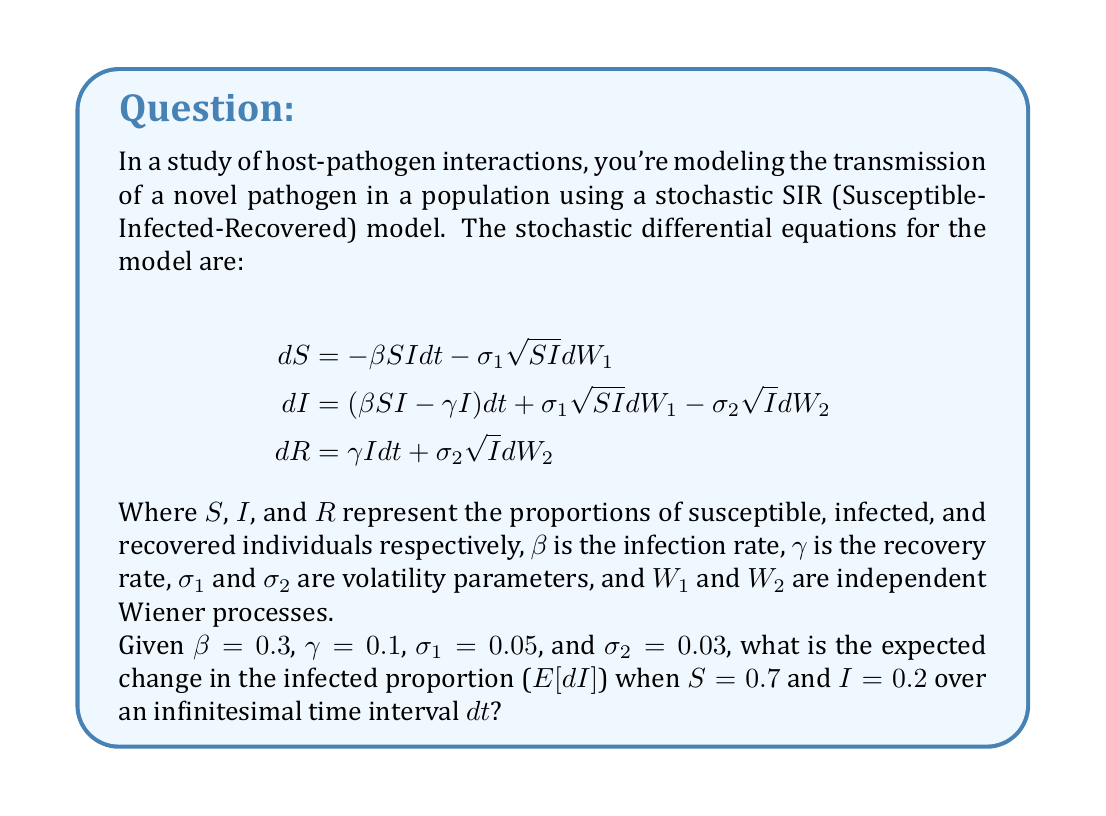Help me with this question. To solve this problem, we need to focus on the equation for $dI$ and calculate its expectation. Let's break it down step-by-step:

1) The stochastic differential equation for $dI$ is:

   $$dI = (\beta SI - \gamma I) dt + \sigma_1 \sqrt{SI} dW_1 - \sigma_2 \sqrt{I} dW_2$$

2) To find $E[dI]$, we need to take the expectation of both sides. The expectation of the Wiener process increments ($dW_1$ and $dW_2$) is zero, so these terms will disappear:

   $$E[dI] = E[(\beta SI - \gamma I) dt + \sigma_1 \sqrt{SI} dW_1 - \sigma_2 \sqrt{I} dW_2]$$
   $$E[dI] = (\beta SI - \gamma I) dt$$

3) Now, we can substitute the given values:
   - $\beta = 0.3$
   - $\gamma = 0.1$
   - $S = 0.7$
   - $I = 0.2$

4) Let's calculate:

   $$E[dI] = (0.3 \cdot 0.7 \cdot 0.2 - 0.1 \cdot 0.2) dt$$
   $$E[dI] = (0.042 - 0.02) dt$$
   $$E[dI] = 0.022 dt$$

Therefore, the expected change in the infected proportion over an infinitesimal time interval $dt$ is $0.022 dt$.
Answer: $0.022 dt$ 